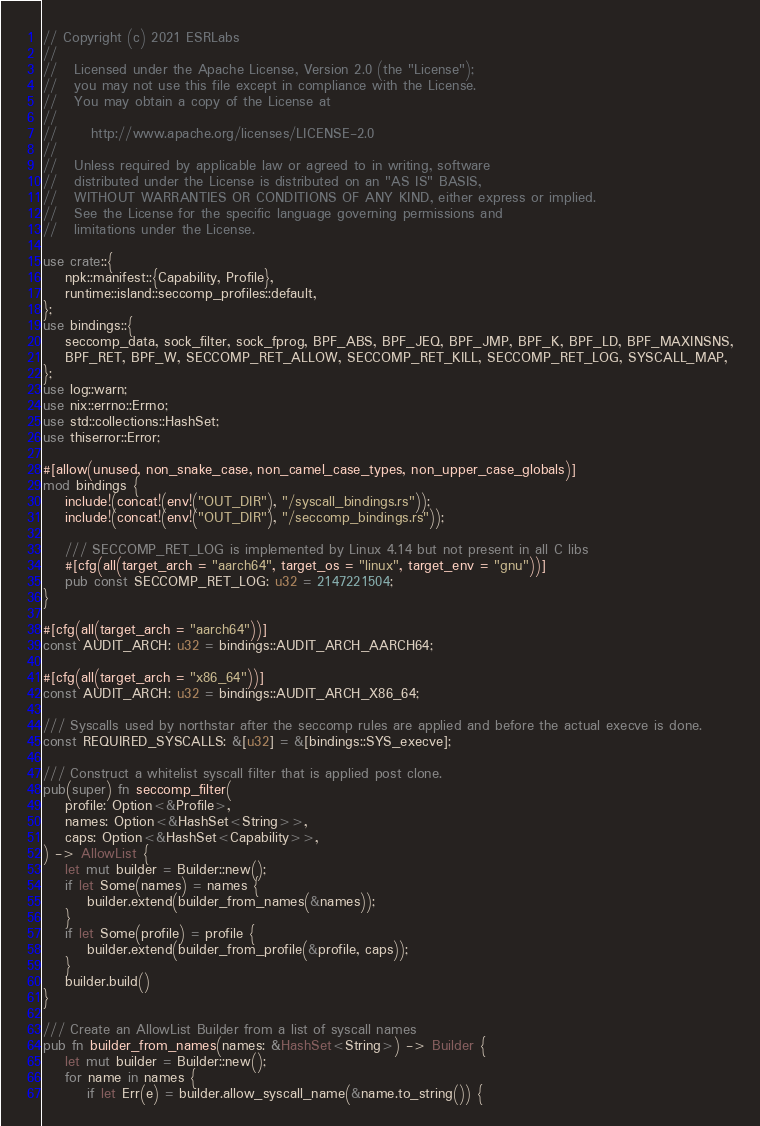<code> <loc_0><loc_0><loc_500><loc_500><_Rust_>// Copyright (c) 2021 ESRLabs
//
//   Licensed under the Apache License, Version 2.0 (the "License");
//   you may not use this file except in compliance with the License.
//   You may obtain a copy of the License at
//
//      http://www.apache.org/licenses/LICENSE-2.0
//
//   Unless required by applicable law or agreed to in writing, software
//   distributed under the License is distributed on an "AS IS" BASIS,
//   WITHOUT WARRANTIES OR CONDITIONS OF ANY KIND, either express or implied.
//   See the License for the specific language governing permissions and
//   limitations under the License.

use crate::{
    npk::manifest::{Capability, Profile},
    runtime::island::seccomp_profiles::default,
};
use bindings::{
    seccomp_data, sock_filter, sock_fprog, BPF_ABS, BPF_JEQ, BPF_JMP, BPF_K, BPF_LD, BPF_MAXINSNS,
    BPF_RET, BPF_W, SECCOMP_RET_ALLOW, SECCOMP_RET_KILL, SECCOMP_RET_LOG, SYSCALL_MAP,
};
use log::warn;
use nix::errno::Errno;
use std::collections::HashSet;
use thiserror::Error;

#[allow(unused, non_snake_case, non_camel_case_types, non_upper_case_globals)]
mod bindings {
    include!(concat!(env!("OUT_DIR"), "/syscall_bindings.rs"));
    include!(concat!(env!("OUT_DIR"), "/seccomp_bindings.rs"));

    /// SECCOMP_RET_LOG is implemented by Linux 4.14 but not present in all C libs
    #[cfg(all(target_arch = "aarch64", target_os = "linux", target_env = "gnu"))]
    pub const SECCOMP_RET_LOG: u32 = 2147221504;
}

#[cfg(all(target_arch = "aarch64"))]
const AUDIT_ARCH: u32 = bindings::AUDIT_ARCH_AARCH64;

#[cfg(all(target_arch = "x86_64"))]
const AUDIT_ARCH: u32 = bindings::AUDIT_ARCH_X86_64;

/// Syscalls used by northstar after the seccomp rules are applied and before the actual execve is done.
const REQUIRED_SYSCALLS: &[u32] = &[bindings::SYS_execve];

/// Construct a whitelist syscall filter that is applied post clone.
pub(super) fn seccomp_filter(
    profile: Option<&Profile>,
    names: Option<&HashSet<String>>,
    caps: Option<&HashSet<Capability>>,
) -> AllowList {
    let mut builder = Builder::new();
    if let Some(names) = names {
        builder.extend(builder_from_names(&names));
    }
    if let Some(profile) = profile {
        builder.extend(builder_from_profile(&profile, caps));
    }
    builder.build()
}

/// Create an AllowList Builder from a list of syscall names
pub fn builder_from_names(names: &HashSet<String>) -> Builder {
    let mut builder = Builder::new();
    for name in names {
        if let Err(e) = builder.allow_syscall_name(&name.to_string()) {</code> 